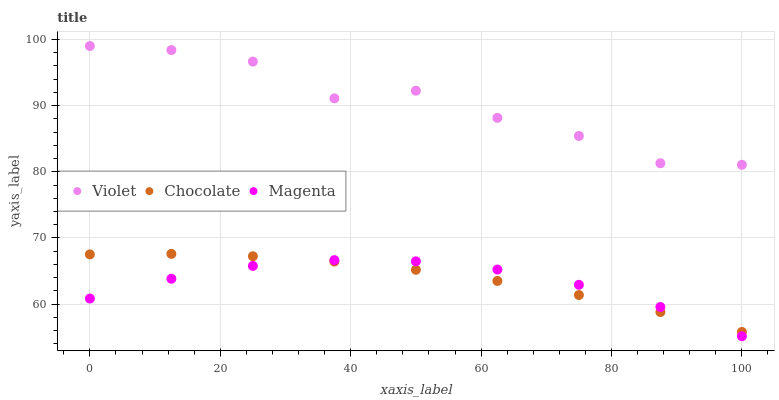Does Magenta have the minimum area under the curve?
Answer yes or no. Yes. Does Violet have the maximum area under the curve?
Answer yes or no. Yes. Does Chocolate have the minimum area under the curve?
Answer yes or no. No. Does Chocolate have the maximum area under the curve?
Answer yes or no. No. Is Chocolate the smoothest?
Answer yes or no. Yes. Is Violet the roughest?
Answer yes or no. Yes. Is Violet the smoothest?
Answer yes or no. No. Is Chocolate the roughest?
Answer yes or no. No. Does Magenta have the lowest value?
Answer yes or no. Yes. Does Chocolate have the lowest value?
Answer yes or no. No. Does Violet have the highest value?
Answer yes or no. Yes. Does Chocolate have the highest value?
Answer yes or no. No. Is Chocolate less than Violet?
Answer yes or no. Yes. Is Violet greater than Magenta?
Answer yes or no. Yes. Does Chocolate intersect Magenta?
Answer yes or no. Yes. Is Chocolate less than Magenta?
Answer yes or no. No. Is Chocolate greater than Magenta?
Answer yes or no. No. Does Chocolate intersect Violet?
Answer yes or no. No. 